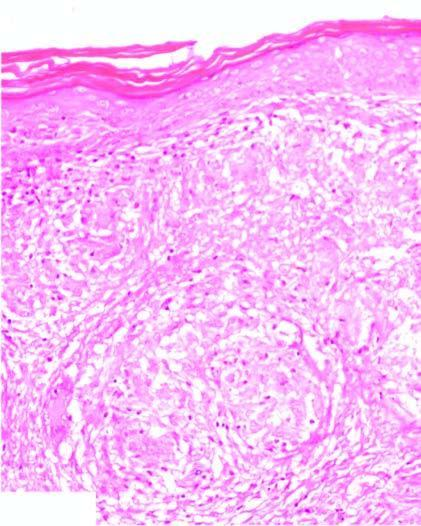does the cystic change show noncaseating epithelioid granulomas having langhans ' giant cells and paucity of lymphocytes, termed as naked granulomas?
Answer the question using a single word or phrase. No 